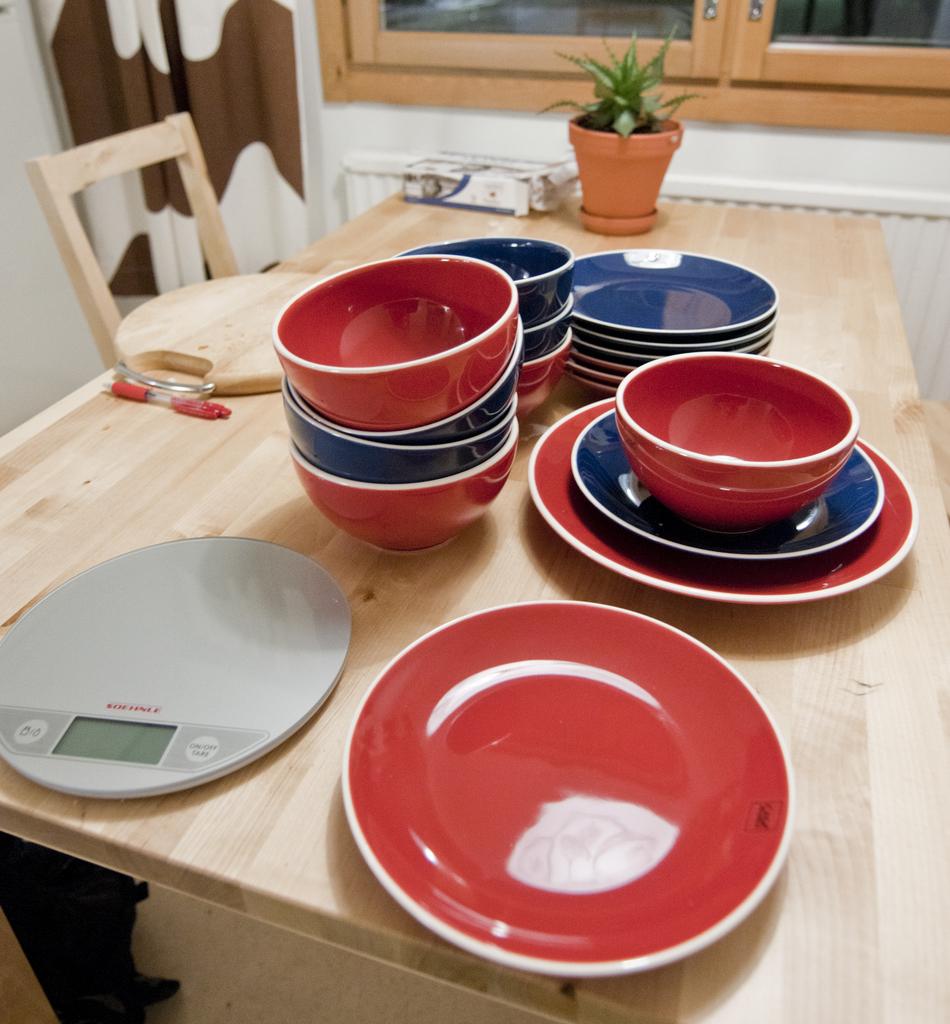Is the on/off switch button on the left or right side?
Your answer should be compact. Right. 